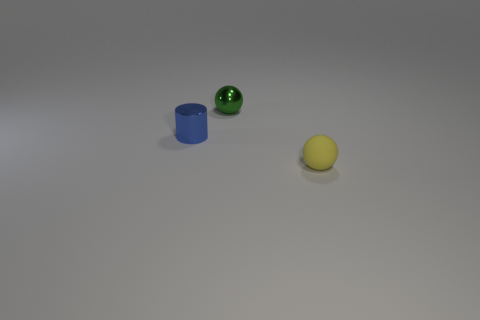There is a tiny object that is right of the green metal object; what material is it?
Keep it short and to the point. Rubber. There is a small green metal object; is its shape the same as the small object that is in front of the blue metallic cylinder?
Ensure brevity in your answer.  Yes. Are there more blue cylinders than objects?
Your answer should be very brief. No. There is another tiny object that is made of the same material as the tiny green thing; what shape is it?
Your answer should be very brief. Cylinder. What material is the ball that is in front of the sphere that is behind the yellow ball?
Your answer should be very brief. Rubber. There is a small metallic thing that is on the right side of the tiny shiny cylinder; is it the same shape as the tiny rubber thing?
Offer a terse response. Yes. Is the number of green balls that are to the right of the blue metallic object greater than the number of purple rubber things?
Give a very brief answer. Yes. Are there any other things that have the same material as the tiny yellow sphere?
Provide a short and direct response. No. What number of balls are tiny matte things or purple rubber objects?
Your response must be concise. 1. There is a tiny object to the right of the thing that is behind the small metallic cylinder; what is its color?
Provide a short and direct response. Yellow. 